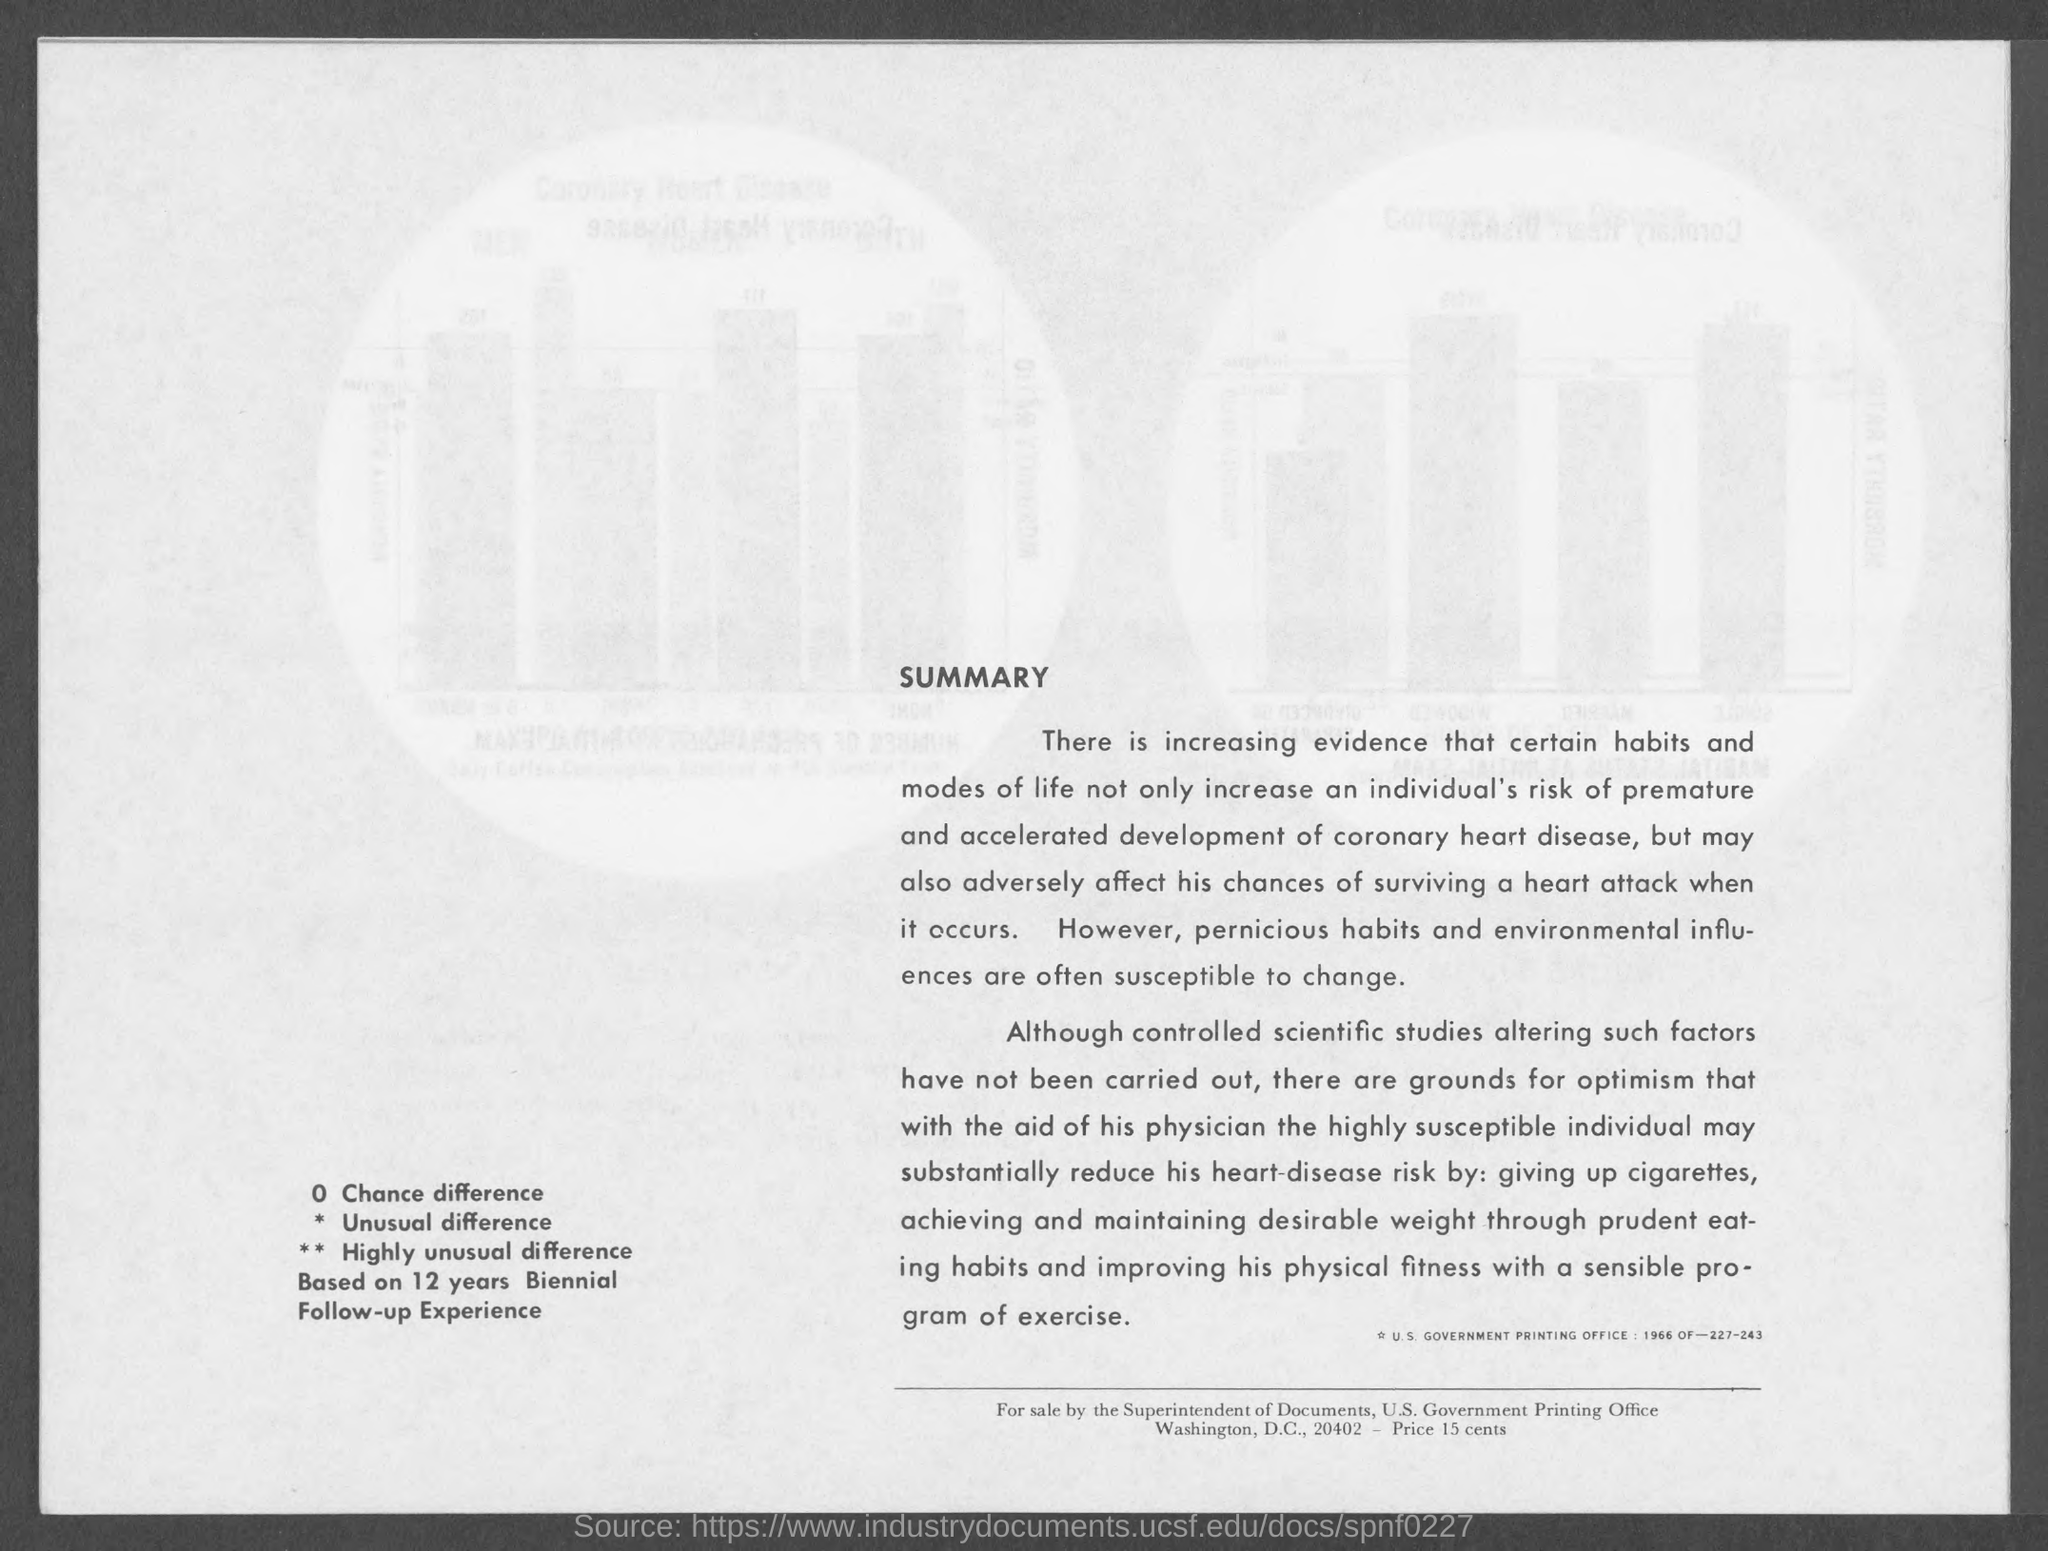For sale by whom?
Make the answer very short. THE SUPERINTENDENT OF DOCUMENTS. What is the Price?
Offer a terse response. 15 CENTS. 